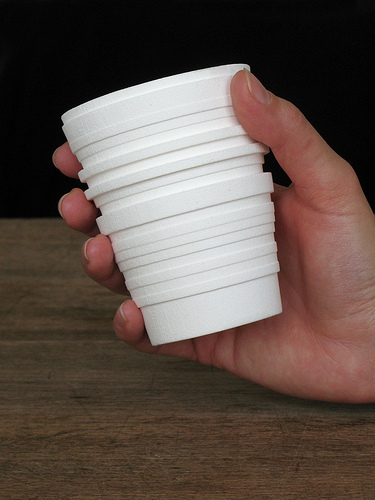<image>
Is the cups on the table? No. The cups is not positioned on the table. They may be near each other, but the cups is not supported by or resting on top of the table. Is there a cup on the table? No. The cup is not positioned on the table. They may be near each other, but the cup is not supported by or resting on top of the table. 